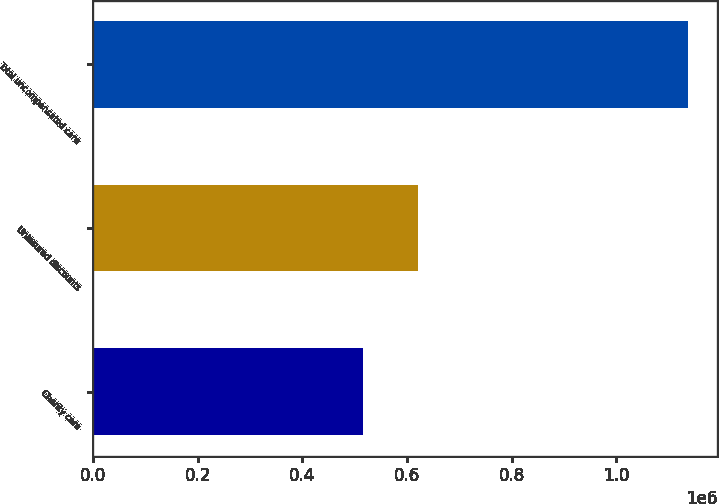Convert chart. <chart><loc_0><loc_0><loc_500><loc_500><bar_chart><fcel>Charity care<fcel>Uninsured discounts<fcel>Total uncompensated care<nl><fcel>515435<fcel>620587<fcel>1.13602e+06<nl></chart> 